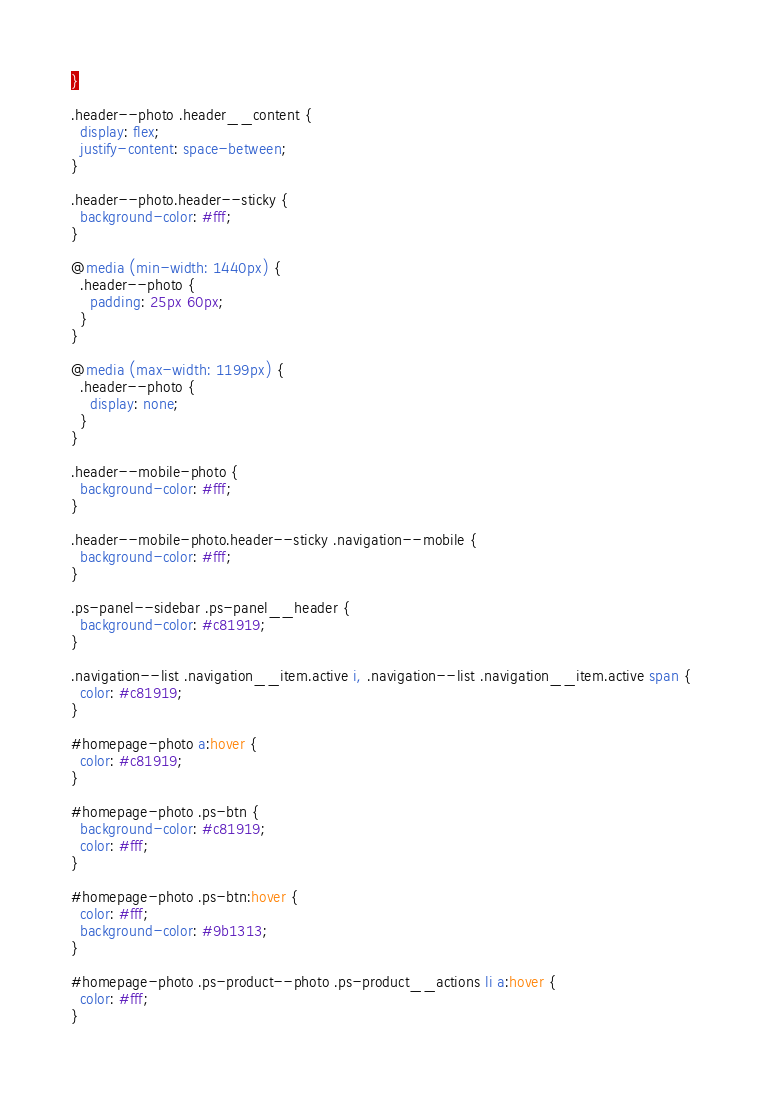<code> <loc_0><loc_0><loc_500><loc_500><_CSS_>}

.header--photo .header__content {
  display: flex;
  justify-content: space-between;
}

.header--photo.header--sticky {
  background-color: #fff;
}

@media (min-width: 1440px) {
  .header--photo {
    padding: 25px 60px;
  }
}

@media (max-width: 1199px) {
  .header--photo {
    display: none;
  }
}

.header--mobile-photo {
  background-color: #fff;
}

.header--mobile-photo.header--sticky .navigation--mobile {
  background-color: #fff;
}

.ps-panel--sidebar .ps-panel__header {
  background-color: #c81919;
}

.navigation--list .navigation__item.active i, .navigation--list .navigation__item.active span {
  color: #c81919;
}

#homepage-photo a:hover {
  color: #c81919;
}

#homepage-photo .ps-btn {
  background-color: #c81919;
  color: #fff;
}

#homepage-photo .ps-btn:hover {
  color: #fff;
  background-color: #9b1313;
}

#homepage-photo .ps-product--photo .ps-product__actions li a:hover {
  color: #fff;
}
</code> 